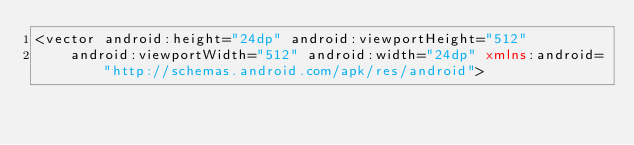<code> <loc_0><loc_0><loc_500><loc_500><_XML_><vector android:height="24dp" android:viewportHeight="512"
    android:viewportWidth="512" android:width="24dp" xmlns:android="http://schemas.android.com/apk/res/android"></code> 